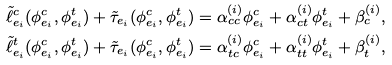<formula> <loc_0><loc_0><loc_500><loc_500>\tilde { \ell } _ { e _ { i } } ^ { c } ( \phi _ { e _ { i } } ^ { c } , \phi _ { e _ { i } } ^ { t } ) + \tilde { \tau } _ { e _ { i } } ( \phi _ { e _ { i } } ^ { c } , \phi _ { e _ { i } } ^ { t } ) & = \alpha _ { c c } ^ { ( i ) } \phi _ { e _ { i } } ^ { c } + \alpha _ { c t } ^ { ( i ) } \phi _ { e _ { i } } ^ { t } + \beta _ { c } ^ { ( i ) } , \\ \tilde { \ell } _ { e _ { i } } ^ { t } ( \phi _ { e _ { i } } ^ { c } , \phi _ { e _ { i } } ^ { t } ) + \tilde { \tau } _ { e _ { i } } ( \phi _ { e _ { i } } ^ { c } , \phi _ { e _ { i } } ^ { t } ) & = \alpha _ { t c } ^ { ( i ) } \phi _ { e _ { i } } ^ { c } + \alpha _ { t t } ^ { ( i ) } \phi _ { e _ { i } } ^ { t } + \beta _ { t } ^ { ( i ) } ,</formula> 